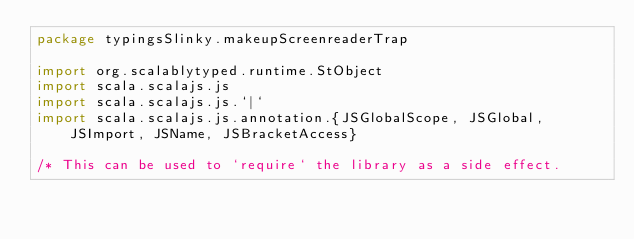Convert code to text. <code><loc_0><loc_0><loc_500><loc_500><_Scala_>package typingsSlinky.makeupScreenreaderTrap

import org.scalablytyped.runtime.StObject
import scala.scalajs.js
import scala.scalajs.js.`|`
import scala.scalajs.js.annotation.{JSGlobalScope, JSGlobal, JSImport, JSName, JSBracketAccess}

/* This can be used to `require` the library as a side effect.</code> 